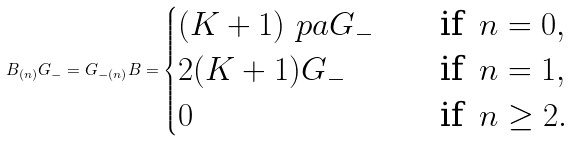<formula> <loc_0><loc_0><loc_500><loc_500>B _ { ( n ) } G _ { - } = G _ { - ( n ) } B = \begin{cases} ( K + 1 ) \ p a G _ { - } & \quad \text {if} \, \ n = 0 , \\ 2 ( K + 1 ) G _ { - } & \quad \text {if} \, \ n = 1 , \\ 0 & \quad \text {if} \, \ n \geq 2 . \end{cases}</formula> 